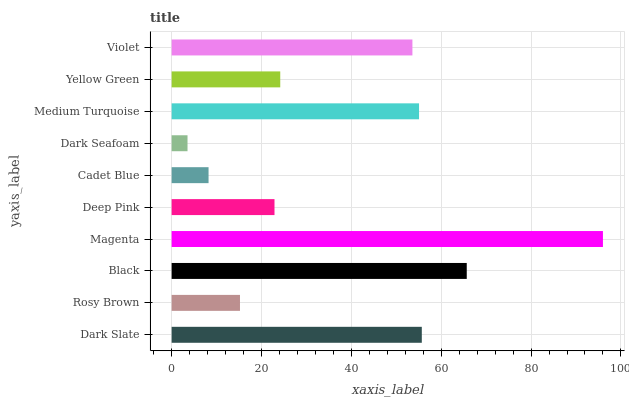Is Dark Seafoam the minimum?
Answer yes or no. Yes. Is Magenta the maximum?
Answer yes or no. Yes. Is Rosy Brown the minimum?
Answer yes or no. No. Is Rosy Brown the maximum?
Answer yes or no. No. Is Dark Slate greater than Rosy Brown?
Answer yes or no. Yes. Is Rosy Brown less than Dark Slate?
Answer yes or no. Yes. Is Rosy Brown greater than Dark Slate?
Answer yes or no. No. Is Dark Slate less than Rosy Brown?
Answer yes or no. No. Is Violet the high median?
Answer yes or no. Yes. Is Yellow Green the low median?
Answer yes or no. Yes. Is Medium Turquoise the high median?
Answer yes or no. No. Is Magenta the low median?
Answer yes or no. No. 